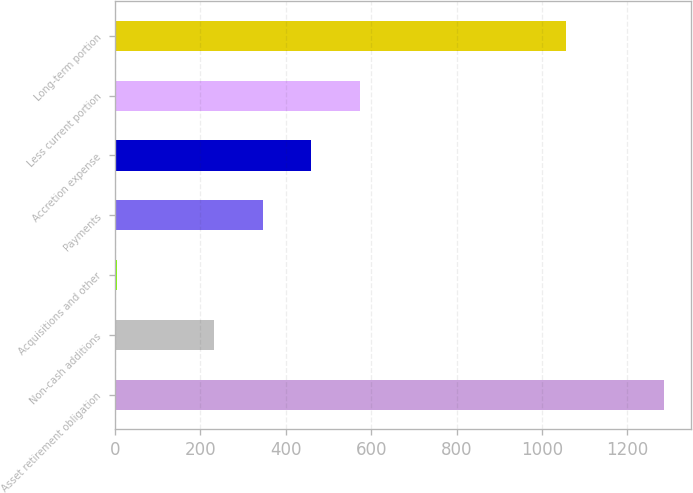<chart> <loc_0><loc_0><loc_500><loc_500><bar_chart><fcel>Asset retirement obligation<fcel>Non-cash additions<fcel>Acquisitions and other<fcel>Payments<fcel>Accretion expense<fcel>Less current portion<fcel>Long-term portion<nl><fcel>1284.5<fcel>231.9<fcel>3.8<fcel>345.95<fcel>460<fcel>574.05<fcel>1056.4<nl></chart> 